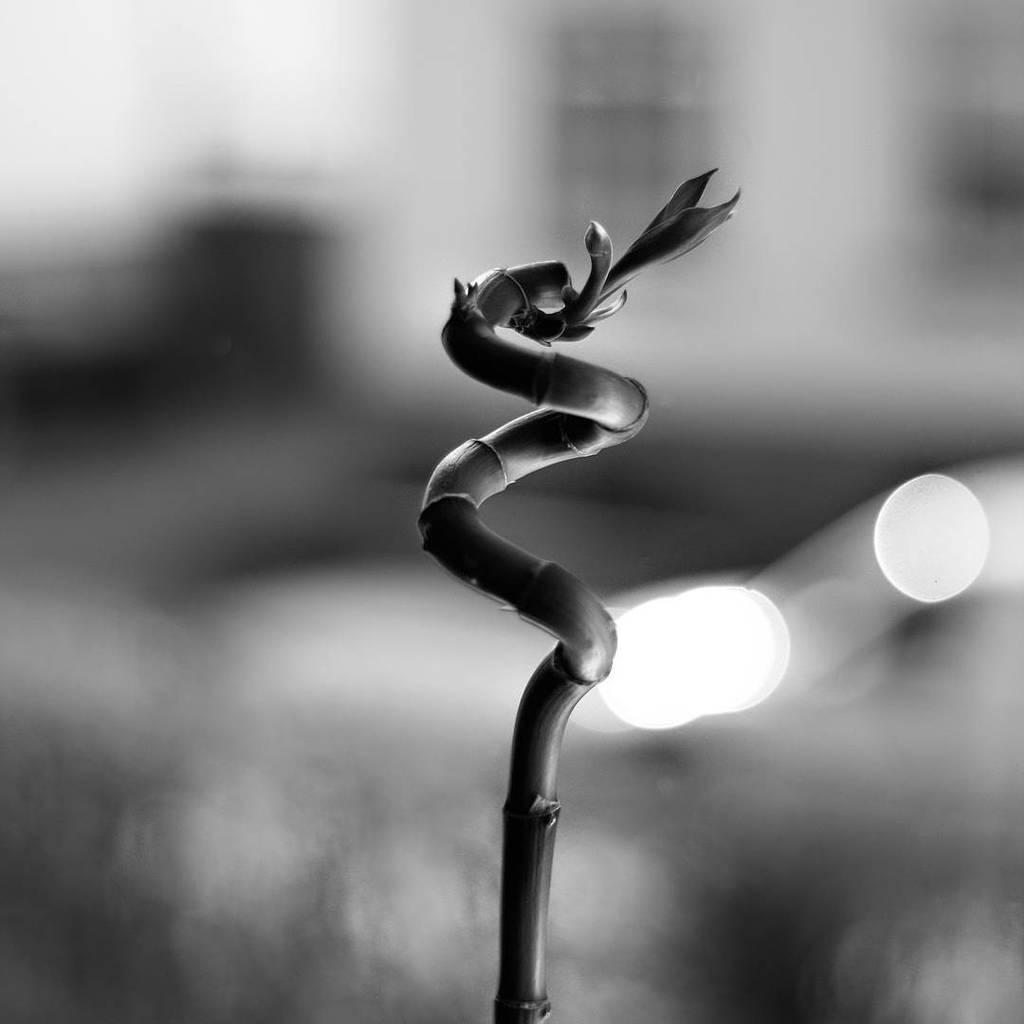What is the main subject of the image? The main subject of the image is a stem of a plant. What can be observed on the stem? The stem has leafs on it. What type of desk is the farmer using to work on the plant in the image? There is no farmer or desk present in the image; it only features a stem of a plant with leafs. What is the relation between the plant and the farmer in the image? There is no farmer present in the image, so there is no relation between the plant and a farmer. 